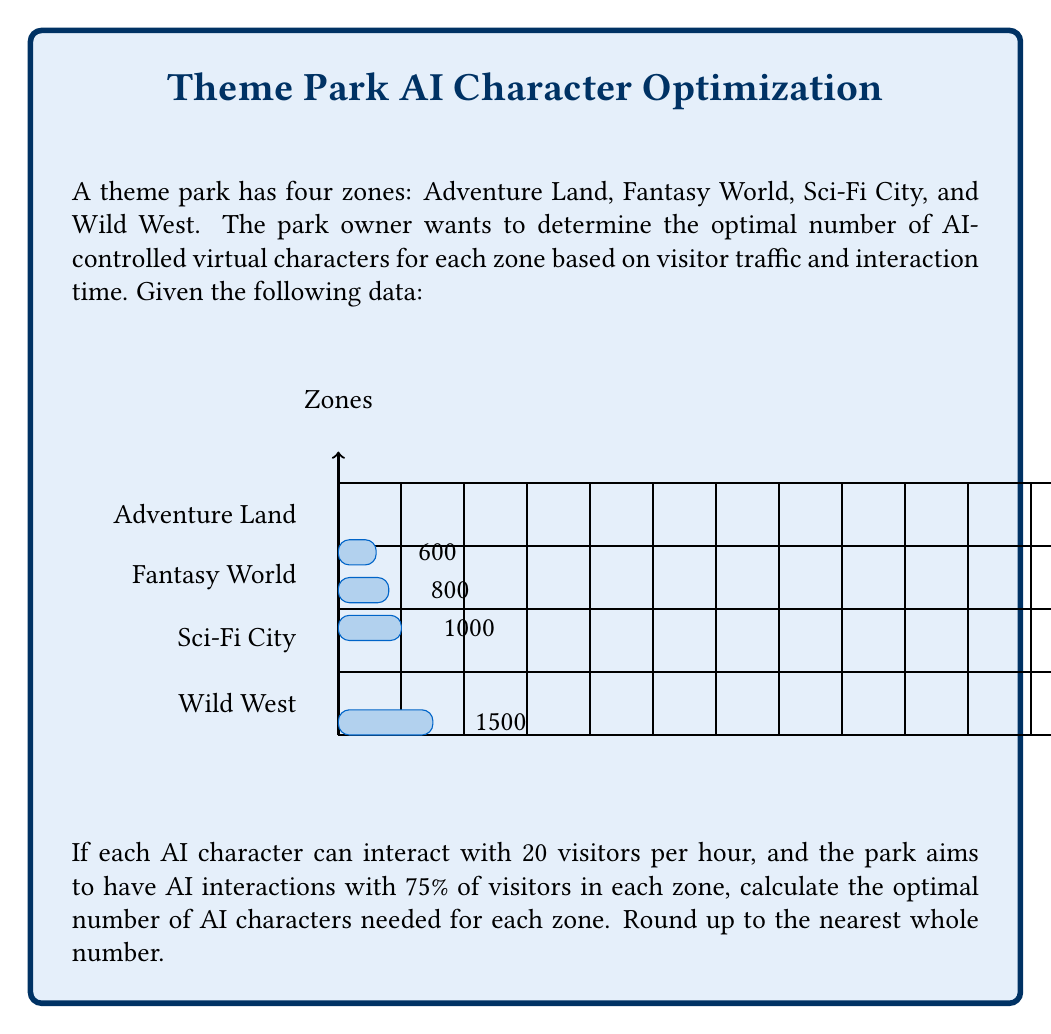What is the answer to this math problem? To solve this problem, we'll follow these steps for each zone:

1. Calculate the number of visitors that should interact with AI (75% of total visitors)
2. Calculate the total interaction time needed
3. Convert the total interaction time to hours
4. Determine the number of AI characters needed

Let's go through each zone:

1. Adventure Land:
   * Visitors for AI interaction: $1000 \times 0.75 = 750$
   * Total interaction time: $750 \times 5 \text{ minutes} = 3750 \text{ minutes}$
   * Interaction time in hours: $3750 \div 60 = 62.5 \text{ hours}$
   * AI characters needed: $62.5 \div 20 = 3.125$, rounded up to 4

2. Fantasy World:
   * Visitors for AI interaction: $1500 \times 0.75 = 1125$
   * Total interaction time: $1125 \times 3 \text{ minutes} = 3375 \text{ minutes}$
   * Interaction time in hours: $3375 \div 60 = 56.25 \text{ hours}$
   * AI characters needed: $56.25 \div 20 = 2.8125$, rounded up to 3

3. Sci-Fi City:
   * Visitors for AI interaction: $800 \times 0.75 = 600$
   * Total interaction time: $600 \times 4 \text{ minutes} = 2400 \text{ minutes}$
   * Interaction time in hours: $2400 \div 60 = 40 \text{ hours}$
   * AI characters needed: $40 \div 20 = 2$

4. Wild West:
   * Visitors for AI interaction: $600 \times 0.75 = 450$
   * Total interaction time: $450 \times 6 \text{ minutes} = 2700 \text{ minutes}$
   * Interaction time in hours: $2700 \div 60 = 45 \text{ hours}$
   * AI characters needed: $45 \div 20 = 2.25$, rounded up to 3

The formula used for each zone is:

$$\text{AI characters} = \left\lceil\frac{\text{Daily visitors} \times 0.75 \times \text{Avg. interaction time (min)}}{60 \text{ min/hour} \times 20 \text{ visitors/hour/AI}}\right\rceil$$
Answer: Adventure Land: 4, Fantasy World: 3, Sci-Fi City: 2, Wild West: 3 